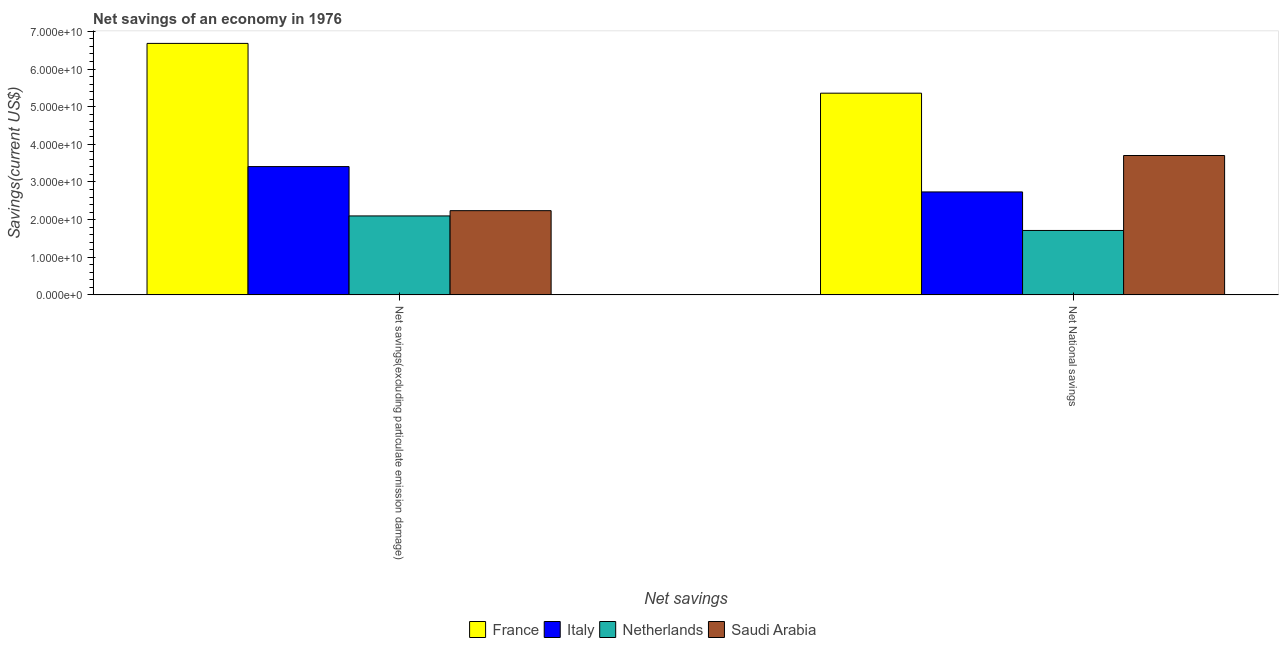How many groups of bars are there?
Make the answer very short. 2. Are the number of bars per tick equal to the number of legend labels?
Keep it short and to the point. Yes. How many bars are there on the 1st tick from the left?
Your answer should be very brief. 4. How many bars are there on the 1st tick from the right?
Provide a succinct answer. 4. What is the label of the 1st group of bars from the left?
Your response must be concise. Net savings(excluding particulate emission damage). What is the net national savings in France?
Provide a short and direct response. 5.36e+1. Across all countries, what is the maximum net savings(excluding particulate emission damage)?
Offer a terse response. 6.68e+1. Across all countries, what is the minimum net savings(excluding particulate emission damage)?
Provide a succinct answer. 2.10e+1. In which country was the net national savings minimum?
Ensure brevity in your answer.  Netherlands. What is the total net savings(excluding particulate emission damage) in the graph?
Your response must be concise. 1.44e+11. What is the difference between the net savings(excluding particulate emission damage) in Netherlands and that in France?
Give a very brief answer. -4.58e+1. What is the difference between the net savings(excluding particulate emission damage) in Italy and the net national savings in Saudi Arabia?
Offer a very short reply. -2.94e+09. What is the average net national savings per country?
Your answer should be very brief. 3.38e+1. What is the difference between the net national savings and net savings(excluding particulate emission damage) in Saudi Arabia?
Give a very brief answer. 1.47e+1. In how many countries, is the net national savings greater than 44000000000 US$?
Offer a terse response. 1. What is the ratio of the net national savings in France to that in Netherlands?
Ensure brevity in your answer.  3.13. What does the 1st bar from the left in Net savings(excluding particulate emission damage) represents?
Your response must be concise. France. What does the 4th bar from the right in Net National savings represents?
Ensure brevity in your answer.  France. Are all the bars in the graph horizontal?
Ensure brevity in your answer.  No. What is the difference between two consecutive major ticks on the Y-axis?
Provide a short and direct response. 1.00e+1. Does the graph contain any zero values?
Your response must be concise. No. Where does the legend appear in the graph?
Offer a very short reply. Bottom center. How many legend labels are there?
Your response must be concise. 4. How are the legend labels stacked?
Keep it short and to the point. Horizontal. What is the title of the graph?
Ensure brevity in your answer.  Net savings of an economy in 1976. What is the label or title of the X-axis?
Keep it short and to the point. Net savings. What is the label or title of the Y-axis?
Your response must be concise. Savings(current US$). What is the Savings(current US$) in France in Net savings(excluding particulate emission damage)?
Your answer should be very brief. 6.68e+1. What is the Savings(current US$) of Italy in Net savings(excluding particulate emission damage)?
Offer a terse response. 3.41e+1. What is the Savings(current US$) of Netherlands in Net savings(excluding particulate emission damage)?
Give a very brief answer. 2.10e+1. What is the Savings(current US$) of Saudi Arabia in Net savings(excluding particulate emission damage)?
Provide a succinct answer. 2.24e+1. What is the Savings(current US$) of France in Net National savings?
Provide a short and direct response. 5.36e+1. What is the Savings(current US$) in Italy in Net National savings?
Provide a succinct answer. 2.74e+1. What is the Savings(current US$) of Netherlands in Net National savings?
Keep it short and to the point. 1.71e+1. What is the Savings(current US$) of Saudi Arabia in Net National savings?
Make the answer very short. 3.70e+1. Across all Net savings, what is the maximum Savings(current US$) of France?
Provide a short and direct response. 6.68e+1. Across all Net savings, what is the maximum Savings(current US$) in Italy?
Keep it short and to the point. 3.41e+1. Across all Net savings, what is the maximum Savings(current US$) in Netherlands?
Ensure brevity in your answer.  2.10e+1. Across all Net savings, what is the maximum Savings(current US$) in Saudi Arabia?
Keep it short and to the point. 3.70e+1. Across all Net savings, what is the minimum Savings(current US$) of France?
Ensure brevity in your answer.  5.36e+1. Across all Net savings, what is the minimum Savings(current US$) in Italy?
Provide a succinct answer. 2.74e+1. Across all Net savings, what is the minimum Savings(current US$) of Netherlands?
Provide a short and direct response. 1.71e+1. Across all Net savings, what is the minimum Savings(current US$) in Saudi Arabia?
Keep it short and to the point. 2.24e+1. What is the total Savings(current US$) in France in the graph?
Your answer should be very brief. 1.20e+11. What is the total Savings(current US$) of Italy in the graph?
Provide a short and direct response. 6.14e+1. What is the total Savings(current US$) of Netherlands in the graph?
Give a very brief answer. 3.81e+1. What is the total Savings(current US$) of Saudi Arabia in the graph?
Provide a succinct answer. 5.94e+1. What is the difference between the Savings(current US$) of France in Net savings(excluding particulate emission damage) and that in Net National savings?
Offer a very short reply. 1.32e+1. What is the difference between the Savings(current US$) in Italy in Net savings(excluding particulate emission damage) and that in Net National savings?
Your answer should be compact. 6.74e+09. What is the difference between the Savings(current US$) in Netherlands in Net savings(excluding particulate emission damage) and that in Net National savings?
Ensure brevity in your answer.  3.86e+09. What is the difference between the Savings(current US$) in Saudi Arabia in Net savings(excluding particulate emission damage) and that in Net National savings?
Offer a very short reply. -1.47e+1. What is the difference between the Savings(current US$) of France in Net savings(excluding particulate emission damage) and the Savings(current US$) of Italy in Net National savings?
Your response must be concise. 3.95e+1. What is the difference between the Savings(current US$) of France in Net savings(excluding particulate emission damage) and the Savings(current US$) of Netherlands in Net National savings?
Provide a succinct answer. 4.97e+1. What is the difference between the Savings(current US$) of France in Net savings(excluding particulate emission damage) and the Savings(current US$) of Saudi Arabia in Net National savings?
Your response must be concise. 2.98e+1. What is the difference between the Savings(current US$) in Italy in Net savings(excluding particulate emission damage) and the Savings(current US$) in Netherlands in Net National savings?
Your response must be concise. 1.70e+1. What is the difference between the Savings(current US$) in Italy in Net savings(excluding particulate emission damage) and the Savings(current US$) in Saudi Arabia in Net National savings?
Your response must be concise. -2.94e+09. What is the difference between the Savings(current US$) in Netherlands in Net savings(excluding particulate emission damage) and the Savings(current US$) in Saudi Arabia in Net National savings?
Your answer should be very brief. -1.61e+1. What is the average Savings(current US$) of France per Net savings?
Your answer should be compact. 6.02e+1. What is the average Savings(current US$) of Italy per Net savings?
Keep it short and to the point. 3.07e+1. What is the average Savings(current US$) in Netherlands per Net savings?
Ensure brevity in your answer.  1.90e+1. What is the average Savings(current US$) of Saudi Arabia per Net savings?
Your answer should be compact. 2.97e+1. What is the difference between the Savings(current US$) of France and Savings(current US$) of Italy in Net savings(excluding particulate emission damage)?
Keep it short and to the point. 3.27e+1. What is the difference between the Savings(current US$) in France and Savings(current US$) in Netherlands in Net savings(excluding particulate emission damage)?
Keep it short and to the point. 4.58e+1. What is the difference between the Savings(current US$) in France and Savings(current US$) in Saudi Arabia in Net savings(excluding particulate emission damage)?
Your response must be concise. 4.44e+1. What is the difference between the Savings(current US$) of Italy and Savings(current US$) of Netherlands in Net savings(excluding particulate emission damage)?
Your response must be concise. 1.31e+1. What is the difference between the Savings(current US$) in Italy and Savings(current US$) in Saudi Arabia in Net savings(excluding particulate emission damage)?
Provide a succinct answer. 1.17e+1. What is the difference between the Savings(current US$) in Netherlands and Savings(current US$) in Saudi Arabia in Net savings(excluding particulate emission damage)?
Provide a short and direct response. -1.40e+09. What is the difference between the Savings(current US$) of France and Savings(current US$) of Italy in Net National savings?
Your response must be concise. 2.62e+1. What is the difference between the Savings(current US$) in France and Savings(current US$) in Netherlands in Net National savings?
Give a very brief answer. 3.65e+1. What is the difference between the Savings(current US$) of France and Savings(current US$) of Saudi Arabia in Net National savings?
Give a very brief answer. 1.66e+1. What is the difference between the Savings(current US$) of Italy and Savings(current US$) of Netherlands in Net National savings?
Give a very brief answer. 1.02e+1. What is the difference between the Savings(current US$) of Italy and Savings(current US$) of Saudi Arabia in Net National savings?
Offer a very short reply. -9.68e+09. What is the difference between the Savings(current US$) of Netherlands and Savings(current US$) of Saudi Arabia in Net National savings?
Offer a very short reply. -1.99e+1. What is the ratio of the Savings(current US$) in France in Net savings(excluding particulate emission damage) to that in Net National savings?
Give a very brief answer. 1.25. What is the ratio of the Savings(current US$) in Italy in Net savings(excluding particulate emission damage) to that in Net National savings?
Give a very brief answer. 1.25. What is the ratio of the Savings(current US$) of Netherlands in Net savings(excluding particulate emission damage) to that in Net National savings?
Your answer should be compact. 1.23. What is the ratio of the Savings(current US$) of Saudi Arabia in Net savings(excluding particulate emission damage) to that in Net National savings?
Offer a terse response. 0.6. What is the difference between the highest and the second highest Savings(current US$) in France?
Offer a terse response. 1.32e+1. What is the difference between the highest and the second highest Savings(current US$) in Italy?
Your response must be concise. 6.74e+09. What is the difference between the highest and the second highest Savings(current US$) of Netherlands?
Provide a short and direct response. 3.86e+09. What is the difference between the highest and the second highest Savings(current US$) in Saudi Arabia?
Give a very brief answer. 1.47e+1. What is the difference between the highest and the lowest Savings(current US$) of France?
Your answer should be very brief. 1.32e+1. What is the difference between the highest and the lowest Savings(current US$) in Italy?
Your response must be concise. 6.74e+09. What is the difference between the highest and the lowest Savings(current US$) in Netherlands?
Provide a succinct answer. 3.86e+09. What is the difference between the highest and the lowest Savings(current US$) in Saudi Arabia?
Keep it short and to the point. 1.47e+1. 